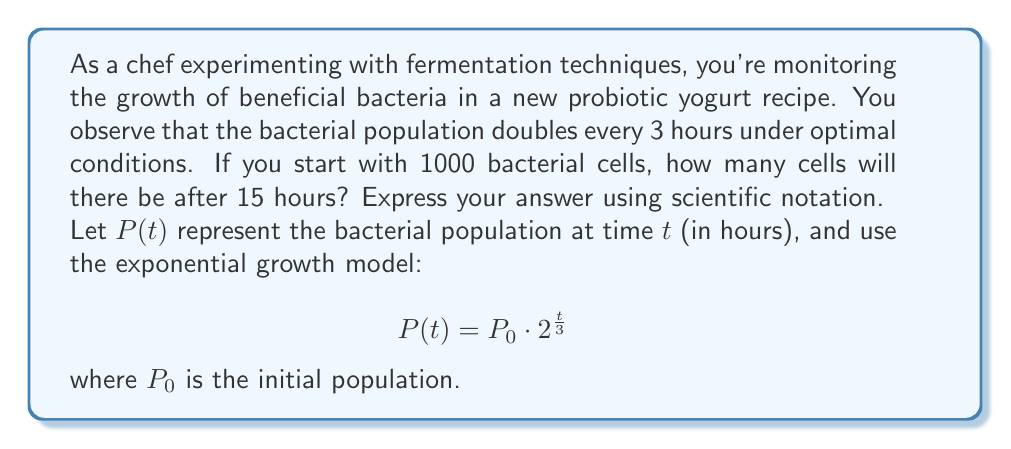Teach me how to tackle this problem. To solve this problem, we'll use the exponential growth model for bacterial populations:

$$P(t) = P_0 \cdot 2^{\frac{t}{3}}$$

Given:
- Initial population, $P_0 = 1000$ cells
- Time, $t = 15$ hours
- Doubling time = 3 hours

Step 1: Substitute the known values into the equation.
$$P(15) = 1000 \cdot 2^{\frac{15}{3}}$$

Step 2: Simplify the exponent.
$$P(15) = 1000 \cdot 2^5$$

Step 3: Calculate $2^5$.
$$P(15) = 1000 \cdot 32$$

Step 4: Multiply.
$$P(15) = 32,000$$

Step 5: Express the result in scientific notation.
$$P(15) = 3.2 \times 10^4$$

Therefore, after 15 hours, there will be $3.2 \times 10^4$ bacterial cells in the yogurt.
Answer: $3.2 \times 10^4$ cells 